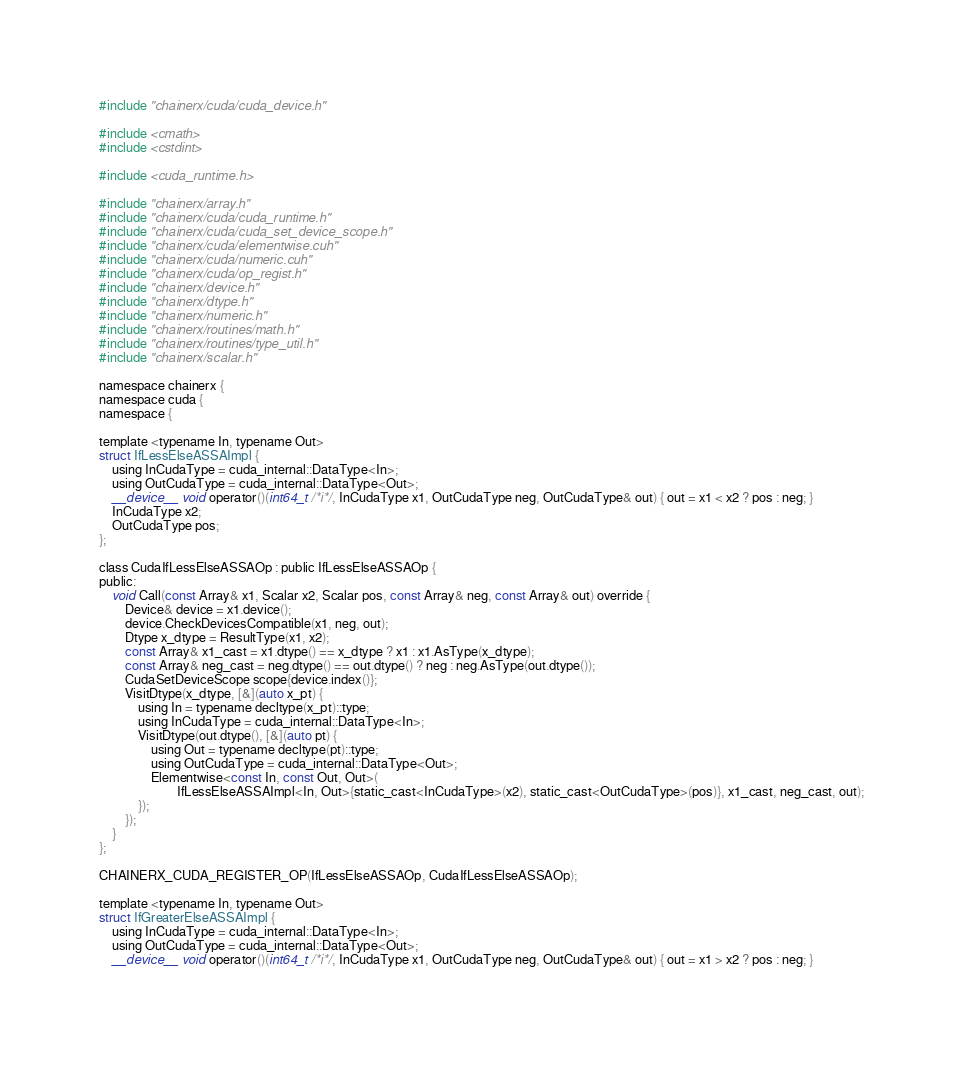<code> <loc_0><loc_0><loc_500><loc_500><_Cuda_>#include "chainerx/cuda/cuda_device.h"

#include <cmath>
#include <cstdint>

#include <cuda_runtime.h>

#include "chainerx/array.h"
#include "chainerx/cuda/cuda_runtime.h"
#include "chainerx/cuda/cuda_set_device_scope.h"
#include "chainerx/cuda/elementwise.cuh"
#include "chainerx/cuda/numeric.cuh"
#include "chainerx/cuda/op_regist.h"
#include "chainerx/device.h"
#include "chainerx/dtype.h"
#include "chainerx/numeric.h"
#include "chainerx/routines/math.h"
#include "chainerx/routines/type_util.h"
#include "chainerx/scalar.h"

namespace chainerx {
namespace cuda {
namespace {

template <typename In, typename Out>
struct IfLessElseASSAImpl {
    using InCudaType = cuda_internal::DataType<In>;
    using OutCudaType = cuda_internal::DataType<Out>;
    __device__ void operator()(int64_t /*i*/, InCudaType x1, OutCudaType neg, OutCudaType& out) { out = x1 < x2 ? pos : neg; }
    InCudaType x2;
    OutCudaType pos;
};

class CudaIfLessElseASSAOp : public IfLessElseASSAOp {
public:
    void Call(const Array& x1, Scalar x2, Scalar pos, const Array& neg, const Array& out) override {
        Device& device = x1.device();
        device.CheckDevicesCompatible(x1, neg, out);
        Dtype x_dtype = ResultType(x1, x2);
        const Array& x1_cast = x1.dtype() == x_dtype ? x1 : x1.AsType(x_dtype);
        const Array& neg_cast = neg.dtype() == out.dtype() ? neg : neg.AsType(out.dtype());
        CudaSetDeviceScope scope{device.index()};
        VisitDtype(x_dtype, [&](auto x_pt) {
            using In = typename decltype(x_pt)::type;
            using InCudaType = cuda_internal::DataType<In>;
            VisitDtype(out.dtype(), [&](auto pt) {
                using Out = typename decltype(pt)::type;
                using OutCudaType = cuda_internal::DataType<Out>;
                Elementwise<const In, const Out, Out>(
                        IfLessElseASSAImpl<In, Out>{static_cast<InCudaType>(x2), static_cast<OutCudaType>(pos)}, x1_cast, neg_cast, out);
            });
        });
    }
};

CHAINERX_CUDA_REGISTER_OP(IfLessElseASSAOp, CudaIfLessElseASSAOp);

template <typename In, typename Out>
struct IfGreaterElseASSAImpl {
    using InCudaType = cuda_internal::DataType<In>;
    using OutCudaType = cuda_internal::DataType<Out>;
    __device__ void operator()(int64_t /*i*/, InCudaType x1, OutCudaType neg, OutCudaType& out) { out = x1 > x2 ? pos : neg; }</code> 